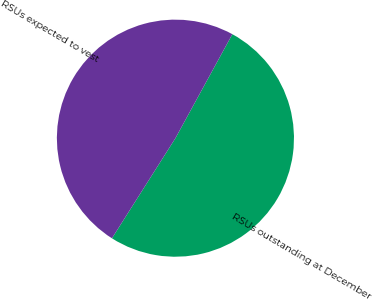<chart> <loc_0><loc_0><loc_500><loc_500><pie_chart><fcel>RSUs outstanding at December<fcel>RSUs expected to vest<nl><fcel>51.02%<fcel>48.98%<nl></chart> 